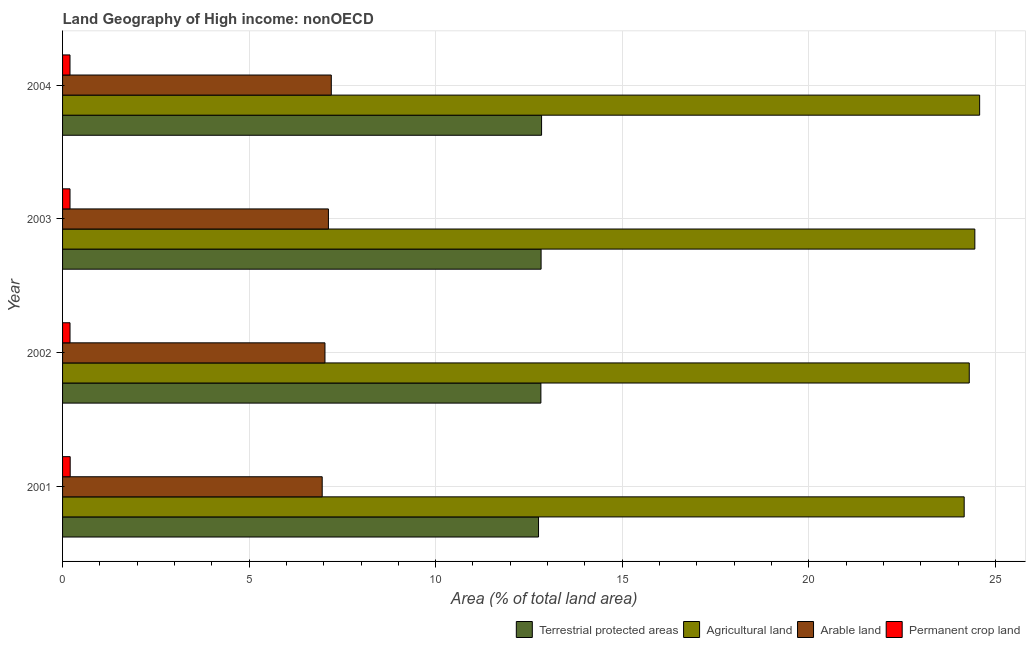Are the number of bars per tick equal to the number of legend labels?
Your answer should be compact. Yes. Are the number of bars on each tick of the Y-axis equal?
Provide a short and direct response. Yes. In how many cases, is the number of bars for a given year not equal to the number of legend labels?
Keep it short and to the point. 0. What is the percentage of area under permanent crop land in 2004?
Give a very brief answer. 0.2. Across all years, what is the maximum percentage of land under terrestrial protection?
Offer a very short reply. 12.84. Across all years, what is the minimum percentage of area under agricultural land?
Offer a very short reply. 24.17. In which year was the percentage of area under agricultural land minimum?
Keep it short and to the point. 2001. What is the total percentage of area under agricultural land in the graph?
Your answer should be compact. 97.5. What is the difference between the percentage of area under agricultural land in 2003 and that in 2004?
Your answer should be very brief. -0.13. What is the difference between the percentage of area under agricultural land in 2003 and the percentage of area under arable land in 2004?
Keep it short and to the point. 17.25. What is the average percentage of area under permanent crop land per year?
Give a very brief answer. 0.2. In the year 2001, what is the difference between the percentage of area under arable land and percentage of area under agricultural land?
Offer a terse response. -17.21. What is the ratio of the percentage of land under terrestrial protection in 2001 to that in 2003?
Provide a succinct answer. 0.99. Is the difference between the percentage of land under terrestrial protection in 2003 and 2004 greater than the difference between the percentage of area under agricultural land in 2003 and 2004?
Offer a terse response. Yes. What is the difference between the highest and the second highest percentage of area under permanent crop land?
Provide a short and direct response. 0.01. What is the difference between the highest and the lowest percentage of area under arable land?
Your response must be concise. 0.24. In how many years, is the percentage of area under arable land greater than the average percentage of area under arable land taken over all years?
Keep it short and to the point. 2. Is the sum of the percentage of land under terrestrial protection in 2001 and 2002 greater than the maximum percentage of area under arable land across all years?
Offer a very short reply. Yes. What does the 4th bar from the top in 2004 represents?
Provide a succinct answer. Terrestrial protected areas. What does the 4th bar from the bottom in 2003 represents?
Ensure brevity in your answer.  Permanent crop land. Are the values on the major ticks of X-axis written in scientific E-notation?
Provide a short and direct response. No. Does the graph contain any zero values?
Offer a very short reply. No. Does the graph contain grids?
Provide a short and direct response. Yes. How many legend labels are there?
Make the answer very short. 4. How are the legend labels stacked?
Offer a very short reply. Horizontal. What is the title of the graph?
Give a very brief answer. Land Geography of High income: nonOECD. What is the label or title of the X-axis?
Keep it short and to the point. Area (% of total land area). What is the Area (% of total land area) of Terrestrial protected areas in 2001?
Offer a very short reply. 12.76. What is the Area (% of total land area) of Agricultural land in 2001?
Keep it short and to the point. 24.17. What is the Area (% of total land area) of Arable land in 2001?
Offer a terse response. 6.96. What is the Area (% of total land area) of Permanent crop land in 2001?
Your response must be concise. 0.2. What is the Area (% of total land area) in Terrestrial protected areas in 2002?
Your response must be concise. 12.82. What is the Area (% of total land area) of Agricultural land in 2002?
Provide a short and direct response. 24.3. What is the Area (% of total land area) of Arable land in 2002?
Your answer should be very brief. 7.03. What is the Area (% of total land area) of Permanent crop land in 2002?
Provide a short and direct response. 0.2. What is the Area (% of total land area) in Terrestrial protected areas in 2003?
Give a very brief answer. 12.83. What is the Area (% of total land area) of Agricultural land in 2003?
Provide a short and direct response. 24.45. What is the Area (% of total land area) in Arable land in 2003?
Offer a terse response. 7.13. What is the Area (% of total land area) in Permanent crop land in 2003?
Give a very brief answer. 0.2. What is the Area (% of total land area) of Terrestrial protected areas in 2004?
Offer a very short reply. 12.84. What is the Area (% of total land area) in Agricultural land in 2004?
Offer a terse response. 24.58. What is the Area (% of total land area) of Arable land in 2004?
Offer a terse response. 7.2. What is the Area (% of total land area) of Permanent crop land in 2004?
Make the answer very short. 0.2. Across all years, what is the maximum Area (% of total land area) in Terrestrial protected areas?
Offer a very short reply. 12.84. Across all years, what is the maximum Area (% of total land area) of Agricultural land?
Give a very brief answer. 24.58. Across all years, what is the maximum Area (% of total land area) in Arable land?
Provide a succinct answer. 7.2. Across all years, what is the maximum Area (% of total land area) of Permanent crop land?
Provide a succinct answer. 0.2. Across all years, what is the minimum Area (% of total land area) in Terrestrial protected areas?
Make the answer very short. 12.76. Across all years, what is the minimum Area (% of total land area) in Agricultural land?
Your response must be concise. 24.17. Across all years, what is the minimum Area (% of total land area) of Arable land?
Your response must be concise. 6.96. Across all years, what is the minimum Area (% of total land area) of Permanent crop land?
Give a very brief answer. 0.2. What is the total Area (% of total land area) in Terrestrial protected areas in the graph?
Provide a short and direct response. 51.24. What is the total Area (% of total land area) in Agricultural land in the graph?
Give a very brief answer. 97.5. What is the total Area (% of total land area) of Arable land in the graph?
Provide a short and direct response. 28.32. What is the total Area (% of total land area) of Permanent crop land in the graph?
Your answer should be compact. 0.8. What is the difference between the Area (% of total land area) in Terrestrial protected areas in 2001 and that in 2002?
Ensure brevity in your answer.  -0.06. What is the difference between the Area (% of total land area) in Agricultural land in 2001 and that in 2002?
Make the answer very short. -0.14. What is the difference between the Area (% of total land area) of Arable land in 2001 and that in 2002?
Provide a succinct answer. -0.07. What is the difference between the Area (% of total land area) in Permanent crop land in 2001 and that in 2002?
Provide a succinct answer. 0. What is the difference between the Area (% of total land area) of Terrestrial protected areas in 2001 and that in 2003?
Your response must be concise. -0.07. What is the difference between the Area (% of total land area) in Agricultural land in 2001 and that in 2003?
Your response must be concise. -0.29. What is the difference between the Area (% of total land area) in Arable land in 2001 and that in 2003?
Offer a very short reply. -0.17. What is the difference between the Area (% of total land area) of Permanent crop land in 2001 and that in 2003?
Your answer should be compact. 0. What is the difference between the Area (% of total land area) in Terrestrial protected areas in 2001 and that in 2004?
Provide a short and direct response. -0.08. What is the difference between the Area (% of total land area) of Agricultural land in 2001 and that in 2004?
Keep it short and to the point. -0.41. What is the difference between the Area (% of total land area) in Arable land in 2001 and that in 2004?
Offer a very short reply. -0.24. What is the difference between the Area (% of total land area) of Permanent crop land in 2001 and that in 2004?
Your response must be concise. 0.01. What is the difference between the Area (% of total land area) in Terrestrial protected areas in 2002 and that in 2003?
Provide a succinct answer. -0.01. What is the difference between the Area (% of total land area) of Agricultural land in 2002 and that in 2003?
Offer a terse response. -0.15. What is the difference between the Area (% of total land area) in Arable land in 2002 and that in 2003?
Keep it short and to the point. -0.09. What is the difference between the Area (% of total land area) of Terrestrial protected areas in 2002 and that in 2004?
Provide a succinct answer. -0.02. What is the difference between the Area (% of total land area) of Agricultural land in 2002 and that in 2004?
Offer a terse response. -0.28. What is the difference between the Area (% of total land area) of Arable land in 2002 and that in 2004?
Provide a succinct answer. -0.17. What is the difference between the Area (% of total land area) in Permanent crop land in 2002 and that in 2004?
Provide a succinct answer. 0. What is the difference between the Area (% of total land area) in Terrestrial protected areas in 2003 and that in 2004?
Offer a terse response. -0.01. What is the difference between the Area (% of total land area) in Agricultural land in 2003 and that in 2004?
Your answer should be compact. -0.13. What is the difference between the Area (% of total land area) in Arable land in 2003 and that in 2004?
Provide a short and direct response. -0.08. What is the difference between the Area (% of total land area) of Permanent crop land in 2003 and that in 2004?
Your answer should be compact. 0. What is the difference between the Area (% of total land area) of Terrestrial protected areas in 2001 and the Area (% of total land area) of Agricultural land in 2002?
Provide a short and direct response. -11.54. What is the difference between the Area (% of total land area) of Terrestrial protected areas in 2001 and the Area (% of total land area) of Arable land in 2002?
Your answer should be very brief. 5.72. What is the difference between the Area (% of total land area) in Terrestrial protected areas in 2001 and the Area (% of total land area) in Permanent crop land in 2002?
Give a very brief answer. 12.56. What is the difference between the Area (% of total land area) of Agricultural land in 2001 and the Area (% of total land area) of Arable land in 2002?
Your answer should be compact. 17.13. What is the difference between the Area (% of total land area) of Agricultural land in 2001 and the Area (% of total land area) of Permanent crop land in 2002?
Give a very brief answer. 23.97. What is the difference between the Area (% of total land area) of Arable land in 2001 and the Area (% of total land area) of Permanent crop land in 2002?
Offer a very short reply. 6.76. What is the difference between the Area (% of total land area) of Terrestrial protected areas in 2001 and the Area (% of total land area) of Agricultural land in 2003?
Your answer should be very brief. -11.69. What is the difference between the Area (% of total land area) in Terrestrial protected areas in 2001 and the Area (% of total land area) in Arable land in 2003?
Give a very brief answer. 5.63. What is the difference between the Area (% of total land area) of Terrestrial protected areas in 2001 and the Area (% of total land area) of Permanent crop land in 2003?
Your answer should be compact. 12.56. What is the difference between the Area (% of total land area) in Agricultural land in 2001 and the Area (% of total land area) in Arable land in 2003?
Offer a terse response. 17.04. What is the difference between the Area (% of total land area) in Agricultural land in 2001 and the Area (% of total land area) in Permanent crop land in 2003?
Provide a succinct answer. 23.97. What is the difference between the Area (% of total land area) of Arable land in 2001 and the Area (% of total land area) of Permanent crop land in 2003?
Provide a short and direct response. 6.76. What is the difference between the Area (% of total land area) in Terrestrial protected areas in 2001 and the Area (% of total land area) in Agricultural land in 2004?
Offer a very short reply. -11.82. What is the difference between the Area (% of total land area) in Terrestrial protected areas in 2001 and the Area (% of total land area) in Arable land in 2004?
Provide a succinct answer. 5.55. What is the difference between the Area (% of total land area) in Terrestrial protected areas in 2001 and the Area (% of total land area) in Permanent crop land in 2004?
Give a very brief answer. 12.56. What is the difference between the Area (% of total land area) in Agricultural land in 2001 and the Area (% of total land area) in Arable land in 2004?
Give a very brief answer. 16.96. What is the difference between the Area (% of total land area) of Agricultural land in 2001 and the Area (% of total land area) of Permanent crop land in 2004?
Your answer should be very brief. 23.97. What is the difference between the Area (% of total land area) of Arable land in 2001 and the Area (% of total land area) of Permanent crop land in 2004?
Your response must be concise. 6.76. What is the difference between the Area (% of total land area) of Terrestrial protected areas in 2002 and the Area (% of total land area) of Agricultural land in 2003?
Offer a terse response. -11.63. What is the difference between the Area (% of total land area) of Terrestrial protected areas in 2002 and the Area (% of total land area) of Arable land in 2003?
Ensure brevity in your answer.  5.69. What is the difference between the Area (% of total land area) in Terrestrial protected areas in 2002 and the Area (% of total land area) in Permanent crop land in 2003?
Offer a very short reply. 12.62. What is the difference between the Area (% of total land area) in Agricultural land in 2002 and the Area (% of total land area) in Arable land in 2003?
Make the answer very short. 17.18. What is the difference between the Area (% of total land area) of Agricultural land in 2002 and the Area (% of total land area) of Permanent crop land in 2003?
Ensure brevity in your answer.  24.1. What is the difference between the Area (% of total land area) of Arable land in 2002 and the Area (% of total land area) of Permanent crop land in 2003?
Provide a short and direct response. 6.83. What is the difference between the Area (% of total land area) in Terrestrial protected areas in 2002 and the Area (% of total land area) in Agricultural land in 2004?
Ensure brevity in your answer.  -11.76. What is the difference between the Area (% of total land area) in Terrestrial protected areas in 2002 and the Area (% of total land area) in Arable land in 2004?
Ensure brevity in your answer.  5.62. What is the difference between the Area (% of total land area) in Terrestrial protected areas in 2002 and the Area (% of total land area) in Permanent crop land in 2004?
Your answer should be very brief. 12.62. What is the difference between the Area (% of total land area) in Agricultural land in 2002 and the Area (% of total land area) in Arable land in 2004?
Provide a succinct answer. 17.1. What is the difference between the Area (% of total land area) in Agricultural land in 2002 and the Area (% of total land area) in Permanent crop land in 2004?
Provide a short and direct response. 24.1. What is the difference between the Area (% of total land area) in Arable land in 2002 and the Area (% of total land area) in Permanent crop land in 2004?
Ensure brevity in your answer.  6.83. What is the difference between the Area (% of total land area) of Terrestrial protected areas in 2003 and the Area (% of total land area) of Agricultural land in 2004?
Keep it short and to the point. -11.75. What is the difference between the Area (% of total land area) in Terrestrial protected areas in 2003 and the Area (% of total land area) in Arable land in 2004?
Your response must be concise. 5.62. What is the difference between the Area (% of total land area) of Terrestrial protected areas in 2003 and the Area (% of total land area) of Permanent crop land in 2004?
Make the answer very short. 12.63. What is the difference between the Area (% of total land area) in Agricultural land in 2003 and the Area (% of total land area) in Arable land in 2004?
Give a very brief answer. 17.25. What is the difference between the Area (% of total land area) in Agricultural land in 2003 and the Area (% of total land area) in Permanent crop land in 2004?
Offer a very short reply. 24.25. What is the difference between the Area (% of total land area) of Arable land in 2003 and the Area (% of total land area) of Permanent crop land in 2004?
Give a very brief answer. 6.93. What is the average Area (% of total land area) in Terrestrial protected areas per year?
Keep it short and to the point. 12.81. What is the average Area (% of total land area) in Agricultural land per year?
Offer a very short reply. 24.37. What is the average Area (% of total land area) of Arable land per year?
Offer a very short reply. 7.08. What is the average Area (% of total land area) of Permanent crop land per year?
Keep it short and to the point. 0.2. In the year 2001, what is the difference between the Area (% of total land area) in Terrestrial protected areas and Area (% of total land area) in Agricultural land?
Ensure brevity in your answer.  -11.41. In the year 2001, what is the difference between the Area (% of total land area) of Terrestrial protected areas and Area (% of total land area) of Arable land?
Your answer should be compact. 5.8. In the year 2001, what is the difference between the Area (% of total land area) of Terrestrial protected areas and Area (% of total land area) of Permanent crop land?
Keep it short and to the point. 12.55. In the year 2001, what is the difference between the Area (% of total land area) of Agricultural land and Area (% of total land area) of Arable land?
Your response must be concise. 17.21. In the year 2001, what is the difference between the Area (% of total land area) of Agricultural land and Area (% of total land area) of Permanent crop land?
Offer a terse response. 23.96. In the year 2001, what is the difference between the Area (% of total land area) of Arable land and Area (% of total land area) of Permanent crop land?
Keep it short and to the point. 6.75. In the year 2002, what is the difference between the Area (% of total land area) in Terrestrial protected areas and Area (% of total land area) in Agricultural land?
Ensure brevity in your answer.  -11.48. In the year 2002, what is the difference between the Area (% of total land area) of Terrestrial protected areas and Area (% of total land area) of Arable land?
Keep it short and to the point. 5.79. In the year 2002, what is the difference between the Area (% of total land area) of Terrestrial protected areas and Area (% of total land area) of Permanent crop land?
Your response must be concise. 12.62. In the year 2002, what is the difference between the Area (% of total land area) in Agricultural land and Area (% of total land area) in Arable land?
Give a very brief answer. 17.27. In the year 2002, what is the difference between the Area (% of total land area) of Agricultural land and Area (% of total land area) of Permanent crop land?
Provide a short and direct response. 24.1. In the year 2002, what is the difference between the Area (% of total land area) of Arable land and Area (% of total land area) of Permanent crop land?
Provide a short and direct response. 6.83. In the year 2003, what is the difference between the Area (% of total land area) in Terrestrial protected areas and Area (% of total land area) in Agricultural land?
Offer a very short reply. -11.63. In the year 2003, what is the difference between the Area (% of total land area) in Terrestrial protected areas and Area (% of total land area) in Arable land?
Provide a short and direct response. 5.7. In the year 2003, what is the difference between the Area (% of total land area) of Terrestrial protected areas and Area (% of total land area) of Permanent crop land?
Offer a terse response. 12.63. In the year 2003, what is the difference between the Area (% of total land area) in Agricultural land and Area (% of total land area) in Arable land?
Your response must be concise. 17.33. In the year 2003, what is the difference between the Area (% of total land area) in Agricultural land and Area (% of total land area) in Permanent crop land?
Provide a short and direct response. 24.25. In the year 2003, what is the difference between the Area (% of total land area) in Arable land and Area (% of total land area) in Permanent crop land?
Keep it short and to the point. 6.93. In the year 2004, what is the difference between the Area (% of total land area) in Terrestrial protected areas and Area (% of total land area) in Agricultural land?
Offer a very short reply. -11.74. In the year 2004, what is the difference between the Area (% of total land area) in Terrestrial protected areas and Area (% of total land area) in Arable land?
Ensure brevity in your answer.  5.64. In the year 2004, what is the difference between the Area (% of total land area) in Terrestrial protected areas and Area (% of total land area) in Permanent crop land?
Give a very brief answer. 12.64. In the year 2004, what is the difference between the Area (% of total land area) of Agricultural land and Area (% of total land area) of Arable land?
Your response must be concise. 17.38. In the year 2004, what is the difference between the Area (% of total land area) in Agricultural land and Area (% of total land area) in Permanent crop land?
Offer a terse response. 24.38. In the year 2004, what is the difference between the Area (% of total land area) in Arable land and Area (% of total land area) in Permanent crop land?
Offer a very short reply. 7. What is the ratio of the Area (% of total land area) in Permanent crop land in 2001 to that in 2002?
Provide a succinct answer. 1.02. What is the ratio of the Area (% of total land area) in Terrestrial protected areas in 2001 to that in 2003?
Your answer should be very brief. 0.99. What is the ratio of the Area (% of total land area) in Agricultural land in 2001 to that in 2003?
Ensure brevity in your answer.  0.99. What is the ratio of the Area (% of total land area) of Arable land in 2001 to that in 2003?
Give a very brief answer. 0.98. What is the ratio of the Area (% of total land area) in Permanent crop land in 2001 to that in 2003?
Give a very brief answer. 1.02. What is the ratio of the Area (% of total land area) of Terrestrial protected areas in 2001 to that in 2004?
Give a very brief answer. 0.99. What is the ratio of the Area (% of total land area) of Agricultural land in 2001 to that in 2004?
Make the answer very short. 0.98. What is the ratio of the Area (% of total land area) of Arable land in 2001 to that in 2004?
Your response must be concise. 0.97. What is the ratio of the Area (% of total land area) in Permanent crop land in 2001 to that in 2004?
Your answer should be compact. 1.03. What is the ratio of the Area (% of total land area) of Agricultural land in 2002 to that in 2003?
Your answer should be compact. 0.99. What is the ratio of the Area (% of total land area) in Agricultural land in 2002 to that in 2004?
Offer a very short reply. 0.99. What is the ratio of the Area (% of total land area) of Arable land in 2002 to that in 2004?
Your answer should be compact. 0.98. What is the ratio of the Area (% of total land area) of Permanent crop land in 2002 to that in 2004?
Your answer should be very brief. 1. What is the ratio of the Area (% of total land area) in Agricultural land in 2003 to that in 2004?
Provide a succinct answer. 0.99. What is the ratio of the Area (% of total land area) in Arable land in 2003 to that in 2004?
Make the answer very short. 0.99. What is the ratio of the Area (% of total land area) in Permanent crop land in 2003 to that in 2004?
Your response must be concise. 1. What is the difference between the highest and the second highest Area (% of total land area) in Terrestrial protected areas?
Your response must be concise. 0.01. What is the difference between the highest and the second highest Area (% of total land area) of Agricultural land?
Give a very brief answer. 0.13. What is the difference between the highest and the second highest Area (% of total land area) in Arable land?
Make the answer very short. 0.08. What is the difference between the highest and the second highest Area (% of total land area) in Permanent crop land?
Offer a very short reply. 0. What is the difference between the highest and the lowest Area (% of total land area) in Terrestrial protected areas?
Ensure brevity in your answer.  0.08. What is the difference between the highest and the lowest Area (% of total land area) in Agricultural land?
Your answer should be compact. 0.41. What is the difference between the highest and the lowest Area (% of total land area) in Arable land?
Your answer should be very brief. 0.24. What is the difference between the highest and the lowest Area (% of total land area) of Permanent crop land?
Your answer should be compact. 0.01. 